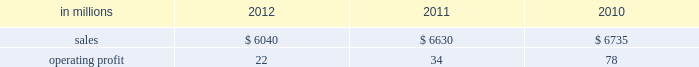Foodservice sales volumes increased in 2012 compared with 2011 .
Average sales margins were higher reflecting the realization of sales price increases for the pass-through of earlier cost increases .
Raw material costs for board and resins were lower .
Operating costs and distribution costs were both higher .
The u.s .
Shorewood business was sold december 31 , 2011 and the non-u.s .
Business was sold in january looking ahead to the first quarter of 2013 , coated paperboard sales volumes are expected to increase slightly from the fourth quarter of 2012 .
Average sales price realizations are expected to be slightly lower , but margins should benefit from a more favorable product mix .
Input costs are expected to be higher for energy and wood .
No planned main- tenance outages are scheduled in the first quarter .
In january 2013 the company announced the perma- nent shutdown of a coated paperboard machine at the augusta mill with an annual capacity of 140000 tons .
Foodservice sales volumes are expected to increase .
Average sales margins are expected to decrease due to the realization of sales price decreases effective with our january contract open- ers .
Input costs for board and resin are expected to be lower and operating costs are also expected to decrease .
European consumer packaging net sales in 2012 were $ 380 million compared with $ 375 million in 2011 and $ 345 million in 2010 .
Operating profits in 2012 were $ 99 million compared with $ 93 million in 2011 and $ 76 million in 2010 .
Sales volumes in 2012 increased from 2011 .
Average sales price realizations were higher in russian markets , but were lower in european markets .
Input costs decreased , primarily for wood , and planned maintenance downtime costs were lower in 2012 than in 2011 .
Looking forward to the first quarter of 2013 , sales volumes are expected to decrease in both europe and russia .
Average sales price realizations are expected to be higher in russia , but be more than offset by decreases in europe .
Input costs are expected to increase for wood and chemicals .
No maintenance outages are scheduled for the first quarter .
Asian consumer packaging net sales were $ 830 million in 2012 compared with $ 855 million in 2011 and $ 705 million in 2010 .
Operating profits in 2012 were $ 4 million compared with $ 35 million in 2011 and $ 34 million in 2010 .
Sales volumes increased in 2012 compared with 2011 partially due to the start-up of a new coated paperboard machine .
Average sales price realizations were significantly lower , but were partially offset by lower input costs for purchased pulp .
Start-up costs for a new coated paperboard machine adversely impacted operating profits in 2012 .
In the first quarter of 2013 , sales volumes are expected to increase slightly .
Average sales price realizations for folding carton board and bristols board are expected to be lower reflecting increased competitive pressures and seasonally weaker market demand .
Input costs should be higher for pulp and chemicals .
However , costs related to the ramp-up of the new coated paperboard machine should be lower .
Distribution xpedx , our distribution business , is one of north america 2019s leading business-to-business distributors to manufacturers , facility managers and printers , providing customized solutions that are designed to improve efficiency , reduce costs and deliver results .
Customer demand is generally sensitive to changes in economic conditions and consumer behavior , along with segment specific activity including corpo- rate advertising and promotional spending , government spending and domestic manufacturing activity .
Distribution 2019s margins are relatively stable across an economic cycle .
Providing customers with the best choice for value in both products and supply chain services is a key competitive factor .
Addition- ally , efficient customer service , cost-effective logis- tics and focused working capital management are key factors in this segment 2019s profitability .
Distribution .
Distr ibut ion 2019s 2012 annual sales decreased 9% ( 9 % ) from 2011 , and decreased 10% ( 10 % ) from 2010 .
Operating profits in 2012 were $ 22 million ( $ 71 million exclud- ing reorganization costs ) compared with $ 34 million ( $ 86 million excluding reorganization costs ) in 2011 and $ 78 million in 2010 .
Annual sales of printing papers and graphic arts supplies and equipment totaled $ 3.5 billion in 2012 compared with $ 4.0 billion in 2011 and $ 4.2 billion in 2010 , reflecting declining demand and the exiting of unprofitable businesses .
Trade margins as a percent of sales for printing papers were relatively even with both 2011 and 2010 .
Revenue from packaging prod- ucts was flat at $ 1.6 billion in both 2012 and 2011 and up slightly compared to $ 1.5 billion in 2010 .
Pack- aging margins increased in 2012 from both 2011 and 2010 , reflecting the successful execution of strategic sourcing initiatives .
Facility supplies annual revenue was $ 0.9 billion in 2012 , down compared to $ 1.0 bil- lion in 2011 and 2010 .
Operating profits in 2012 included $ 49 million of reorganization costs for severance , professional services and asset write-downs compared with $ 52 .
What percent of distribution sales where attributable to printing papers and graphic arts supplies and equipment in 2012? 
Computations: ((3.5 * 1000) / 6040)
Answer: 0.57947. 